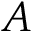<formula> <loc_0><loc_0><loc_500><loc_500>A</formula> 